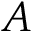<formula> <loc_0><loc_0><loc_500><loc_500>A</formula> 